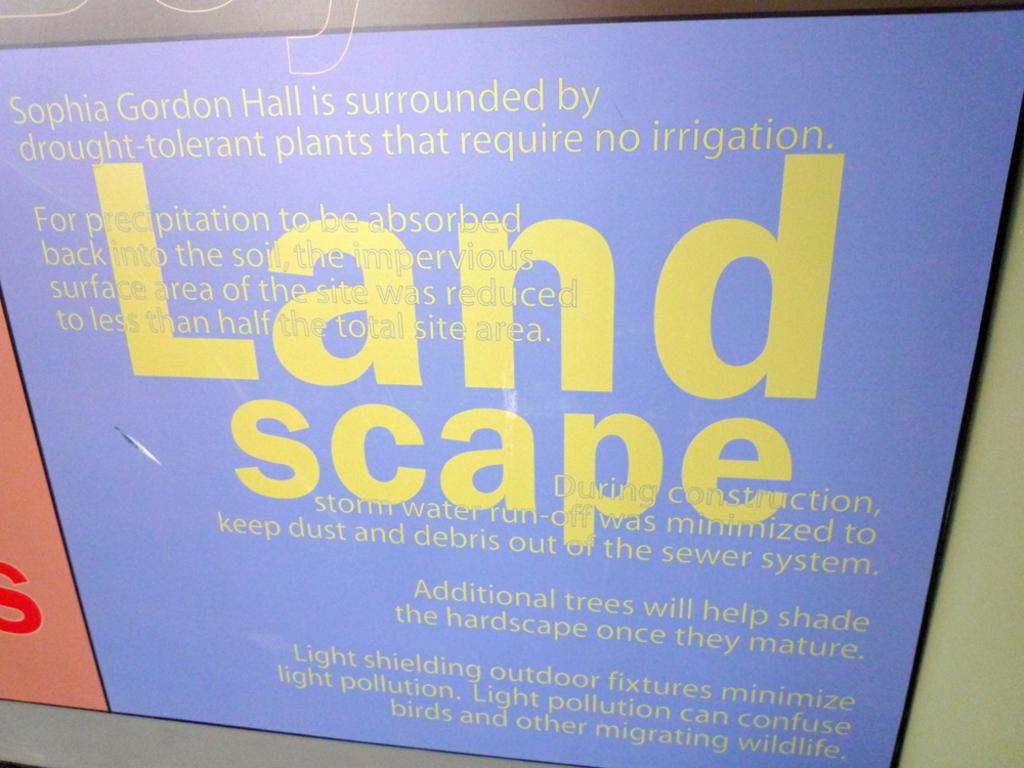Is it best to keep dust and debris out of the sewer system?
Offer a terse response. Yes. What is the sign for?
Provide a short and direct response. Landscape. 